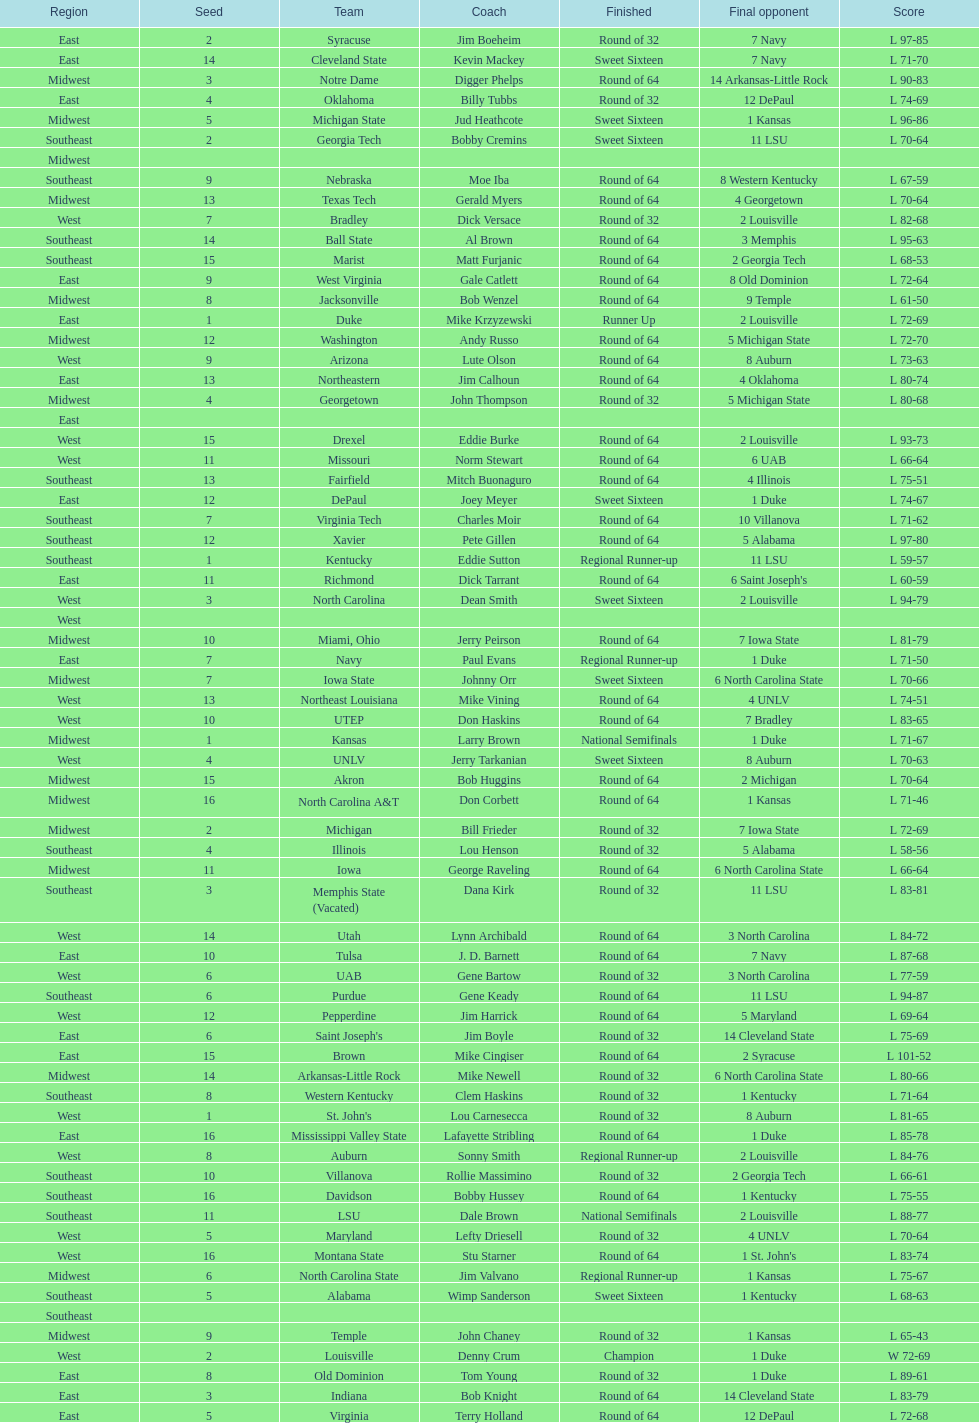What geographical section is stated before the midwest? West. 